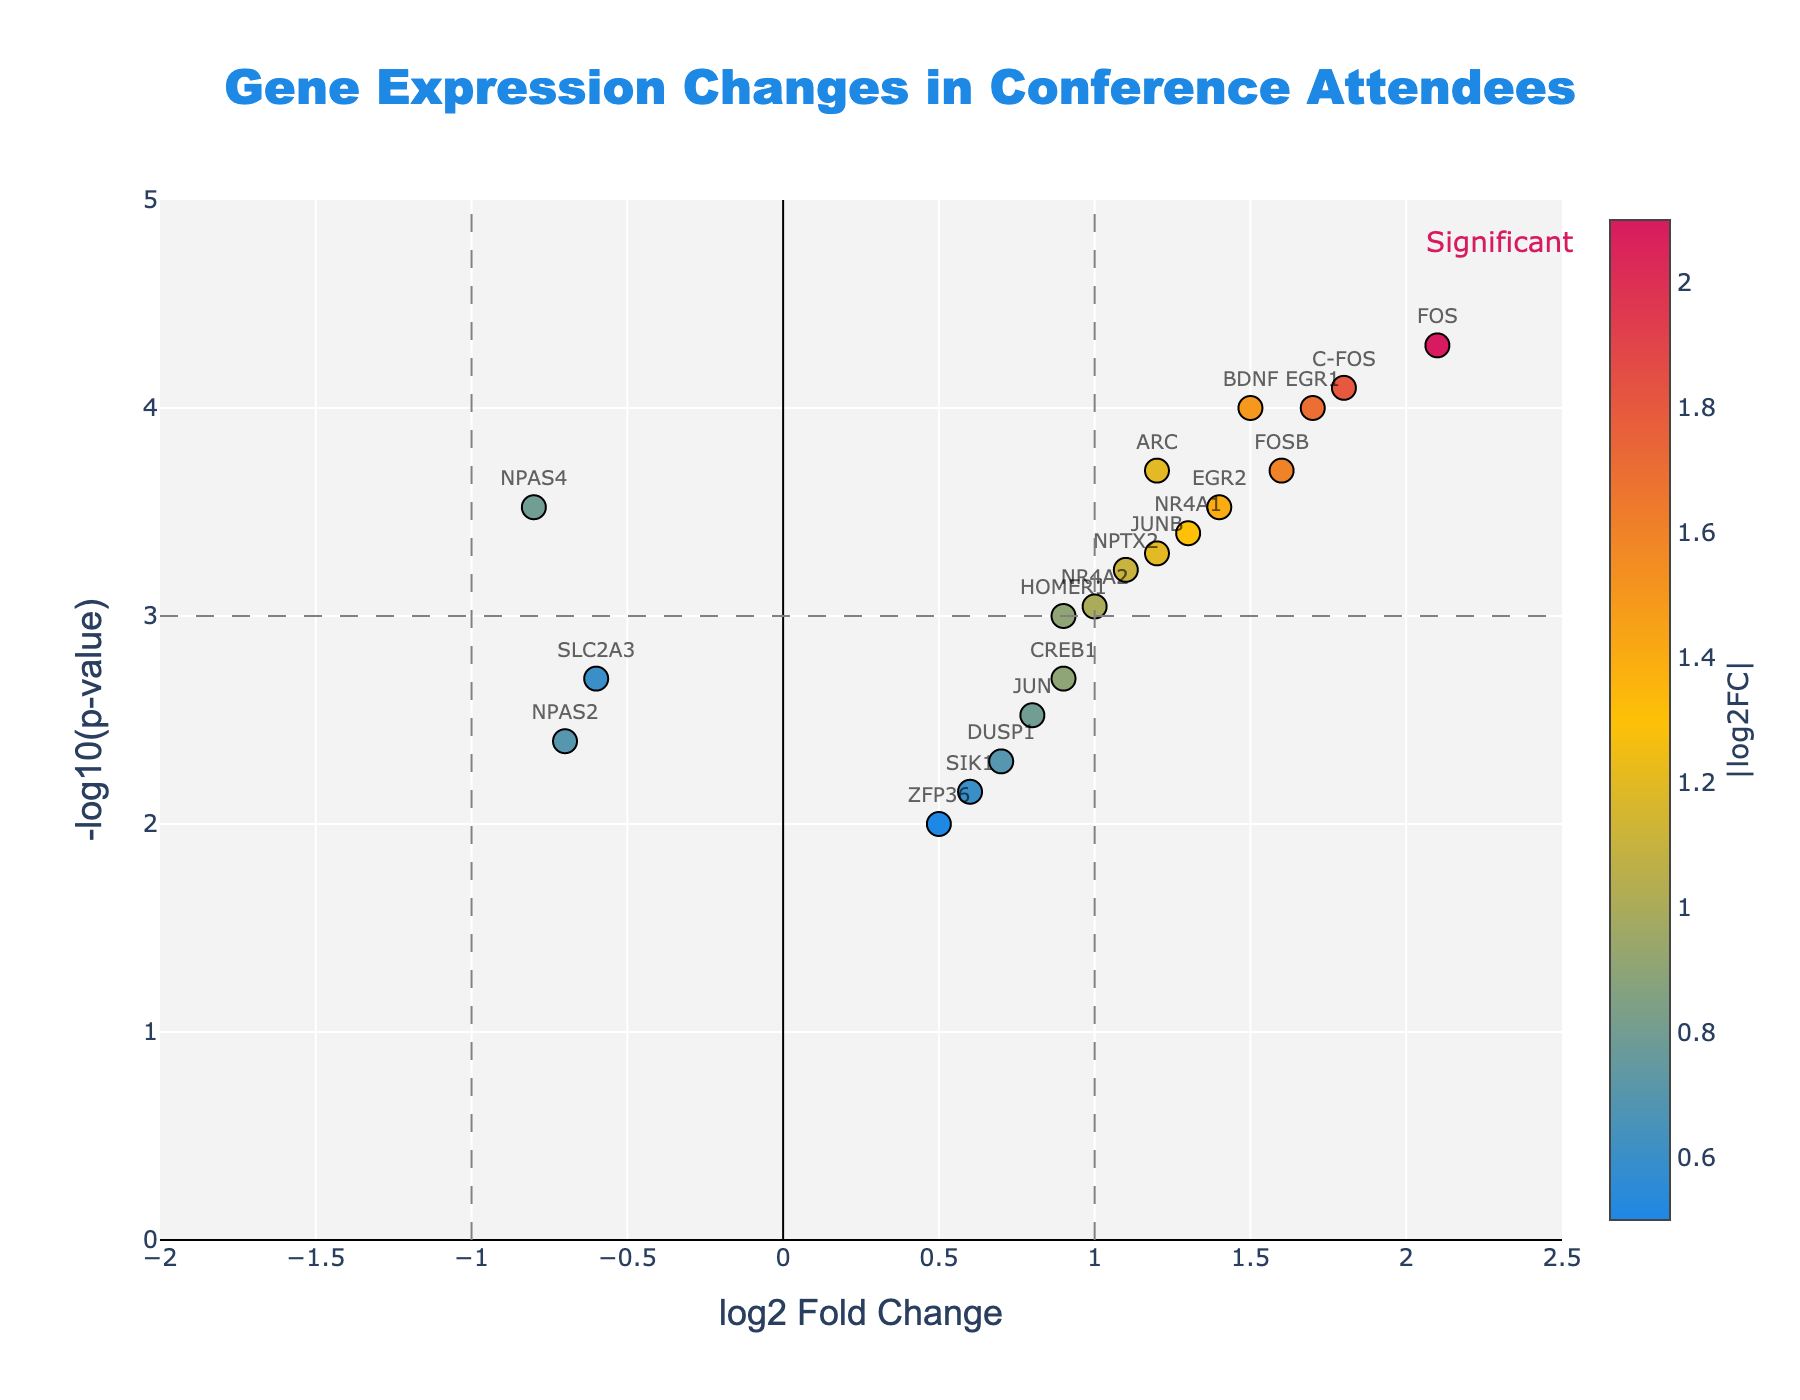Which gene has the highest log2 fold change? To find the gene with the highest log2 fold change, locate the data point with the largest x-axis value. The gene label associated with this data point is "FOS" with a log2 fold change of 2.1
Answer: FOS What is the title of the figure? The title of the figure is prominently displayed at the top center of the plot. It reads "Gene Expression Changes in Conference Attendees."
Answer: Gene Expression Changes in Conference Attendees How many genes have a log2 fold change greater than 1? To determine the number of genes with a log2 fold change greater than 1, count the points to the right of the vertical line at x=1. These genes include BDNF, ARC, FOS, EGR1, NR4A1, NPTX2, C-FOS, NR4A2, FOSB, JUNB, and EGR2, totaling 11 genes
Answer: 11 Which gene has the smallest p-value? The smallest p-value corresponds to the highest value on the y-axis (-log10(p-value)). The gene with the highest y-axis value is "FOS"
Answer: FOS What is the log2 fold change and p-value of the gene with the smallest log2 fold change among genes that have a p-value less than 0.001? First, identify genes with p-values less than 0.001, marked by the horizontal line. Among them, find the gene with the smallest log2 fold change. This gene is "NPAS4" with a log2 fold change of -0.8 and a p-value of 0.0003
Answer: log2FC: -0.8, p-value: 0.0003 Which genes are below the p-value threshold but have a log2 fold change less than 1? Identify genes below the horizontal threshold line (p-value < 0.001) and left of the vertical line at x=1. These genes are NPAS4 and HOMER1
Answer: NPAS4, HOMER1 How many overall genes are included in the plot? To find the total number of genes, simply count all the points plotted. There are 20 data points corresponding to 20 genes
Answer: 20 How many genes have both a log2 fold change greater than 1 and a p-value less than 0.001? Count the points to the right of the vertical line at x=1 and below the horizontal line for p-value < 0.001. The genes are BDNF, ARC, FOS, EGR1, NR4A1, C-FOS, FOSB, JUNB, and EGR2, making it 9 genes
Answer: 9 Which gene has a log2 fold change closest to zero but still considered significant using the p-value threshold? To find this, look for the data point closest to x=0, but below the p-value threshold line. The gene "DUSP1" has a log2 fold change of 0.7 and p-value of 0.005, which does not meet the p-value threshold. Similarly, find the closest among significant genes; the closest one is "NR4A2" with a log2 fold change of 1.0
Answer: NR4A2 Which genes have a log2 fold change equal to or greater than 1 and are considered significant? Identify all genes to the right of the vertical line at x=1 and below the p-value threshold line. These genes include BDNF, ARC, FOS, EGR1, NR4A1, C-FOS, FOSB, JUNB, and EGR2
Answer: BDNF, ARC, FOS, EGR1, NR4A1, C-FOS, FOSB, JUNB, EGR2 